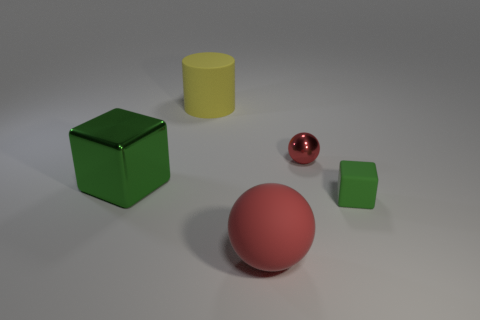What material is the other block that is the same color as the large metal block?
Offer a terse response. Rubber. There is a tiny metal sphere; is its color the same as the big rubber object in front of the big metallic block?
Provide a short and direct response. Yes. Is the color of the shiny block the same as the tiny rubber cube?
Offer a very short reply. Yes. There is a large red object; is it the same shape as the metallic object behind the large green cube?
Your answer should be very brief. Yes. How many cyan shiny cylinders have the same size as the rubber cylinder?
Your response must be concise. 0. What is the material of the tiny object that is the same shape as the large red object?
Your response must be concise. Metal. Is the color of the metal object that is behind the shiny block the same as the sphere that is in front of the small red object?
Your answer should be compact. Yes. There is a big matte thing that is in front of the matte cylinder; what is its shape?
Provide a succinct answer. Sphere. What is the color of the small ball?
Make the answer very short. Red. What shape is the big thing that is made of the same material as the big ball?
Your response must be concise. Cylinder. 